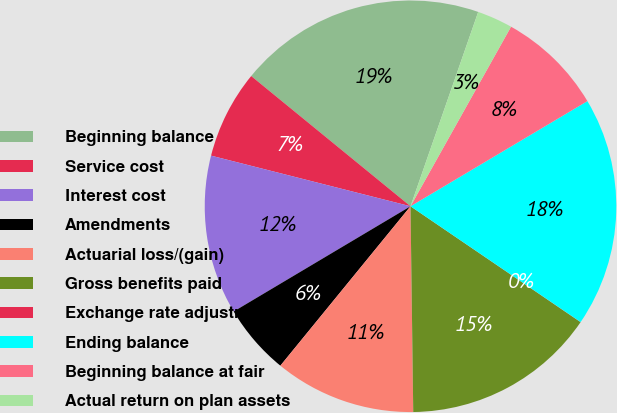<chart> <loc_0><loc_0><loc_500><loc_500><pie_chart><fcel>Beginning balance<fcel>Service cost<fcel>Interest cost<fcel>Amendments<fcel>Actuarial loss/(gain)<fcel>Gross benefits paid<fcel>Exchange rate adjustment<fcel>Ending balance<fcel>Beginning balance at fair<fcel>Actual return on plan assets<nl><fcel>19.43%<fcel>6.95%<fcel>12.5%<fcel>5.56%<fcel>11.11%<fcel>15.27%<fcel>0.01%<fcel>18.05%<fcel>8.34%<fcel>2.79%<nl></chart> 